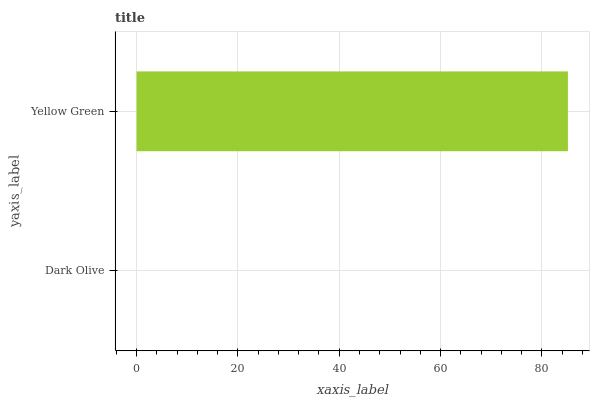Is Dark Olive the minimum?
Answer yes or no. Yes. Is Yellow Green the maximum?
Answer yes or no. Yes. Is Yellow Green the minimum?
Answer yes or no. No. Is Yellow Green greater than Dark Olive?
Answer yes or no. Yes. Is Dark Olive less than Yellow Green?
Answer yes or no. Yes. Is Dark Olive greater than Yellow Green?
Answer yes or no. No. Is Yellow Green less than Dark Olive?
Answer yes or no. No. Is Yellow Green the high median?
Answer yes or no. Yes. Is Dark Olive the low median?
Answer yes or no. Yes. Is Dark Olive the high median?
Answer yes or no. No. Is Yellow Green the low median?
Answer yes or no. No. 